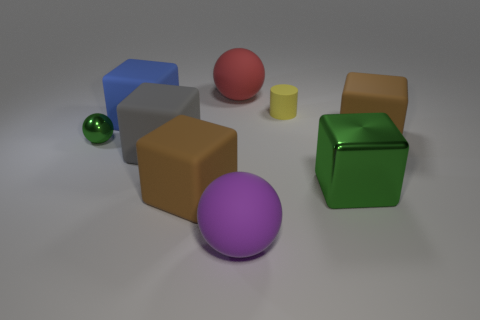Subtract all green blocks. How many blocks are left? 4 Subtract all large green cubes. How many cubes are left? 4 Subtract all purple cubes. Subtract all yellow spheres. How many cubes are left? 5 Add 1 big gray rubber cubes. How many objects exist? 10 Subtract all blocks. How many objects are left? 4 Subtract 0 yellow blocks. How many objects are left? 9 Subtract all small blue rubber blocks. Subtract all tiny yellow objects. How many objects are left? 8 Add 5 large balls. How many large balls are left? 7 Add 4 small spheres. How many small spheres exist? 5 